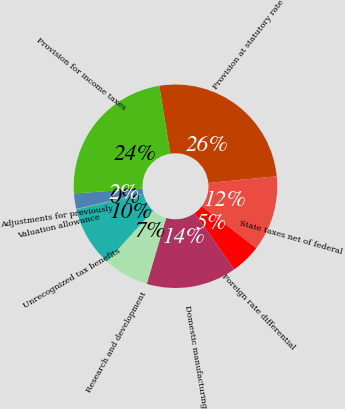Convert chart. <chart><loc_0><loc_0><loc_500><loc_500><pie_chart><fcel>Provision at statutory rate<fcel>State taxes net of federal<fcel>Foreign rate differential<fcel>Domestic manufacturing<fcel>Research and development<fcel>Unrecognized tax benefits<fcel>Valuation allowance<fcel>Adjustments for previously<fcel>Provision for income taxes<nl><fcel>25.97%<fcel>11.96%<fcel>4.83%<fcel>14.34%<fcel>7.21%<fcel>9.59%<fcel>0.07%<fcel>2.45%<fcel>23.59%<nl></chart> 